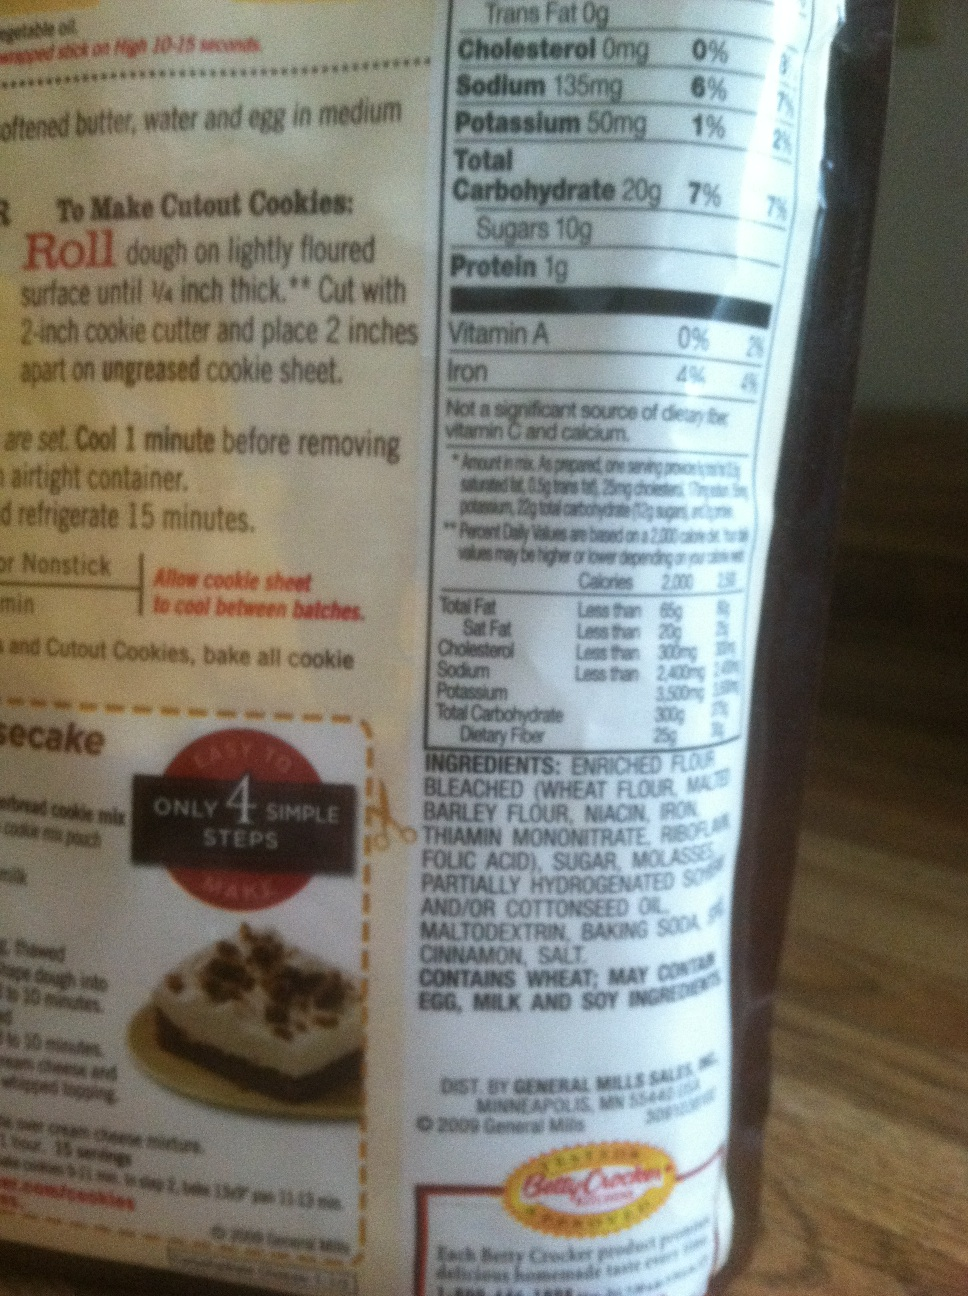What is in this bag? This bag contains a baking mix, specifically for making desserts like cookies. The primary ingredient is enriched bleached flour, which includes wheat flour, barley flour, and several supplements like niacin, iron, and thiamin mononitrate. Other ingredients listed are sugar, molasses, partially hydrogenated soybean and/or cottonseed oil, maltodextrin, baking soda, and various spices and additives. 